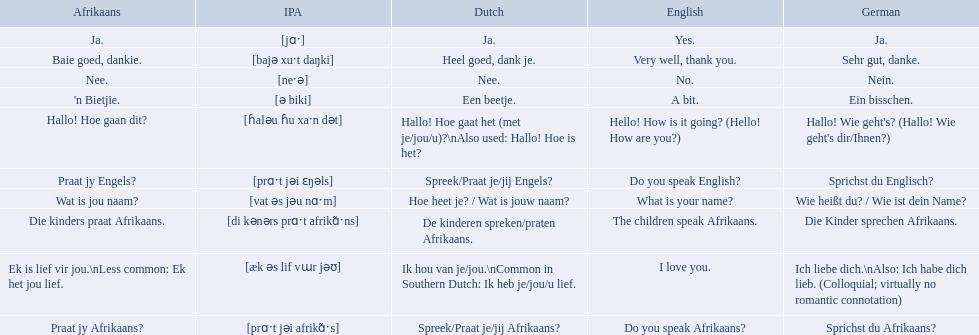How would you say the phrase the children speak afrikaans in afrikaans? Die kinders praat Afrikaans. How would you say the previous phrase in german? Die Kinder sprechen Afrikaans. 